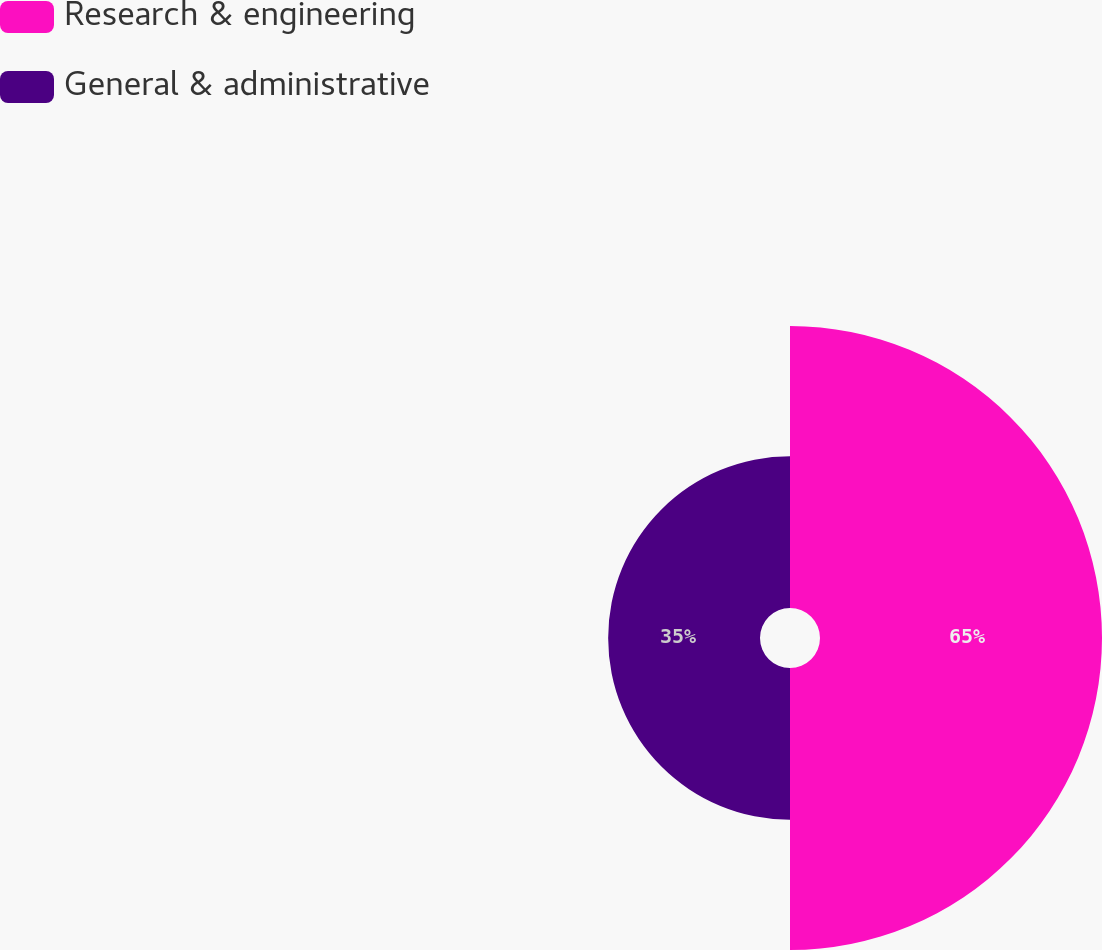<chart> <loc_0><loc_0><loc_500><loc_500><pie_chart><fcel>Research & engineering<fcel>General & administrative<nl><fcel>65.0%<fcel>35.0%<nl></chart> 